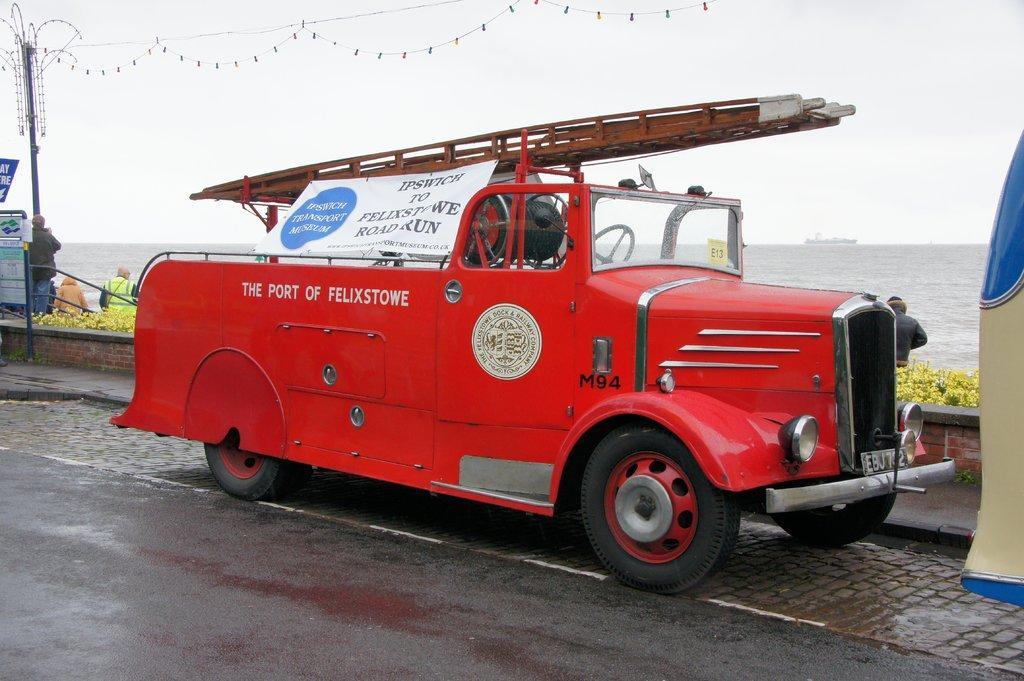Can you describe this image briefly? In the middle of this image, there is a red color vehicle having a ladder and a banner on the top of this vehicle. On the left side, there is another vehicle. In the background, there are plants, person's, a pole, a sign board, a boat on the water of the ocean and there are clouds in the sky. 